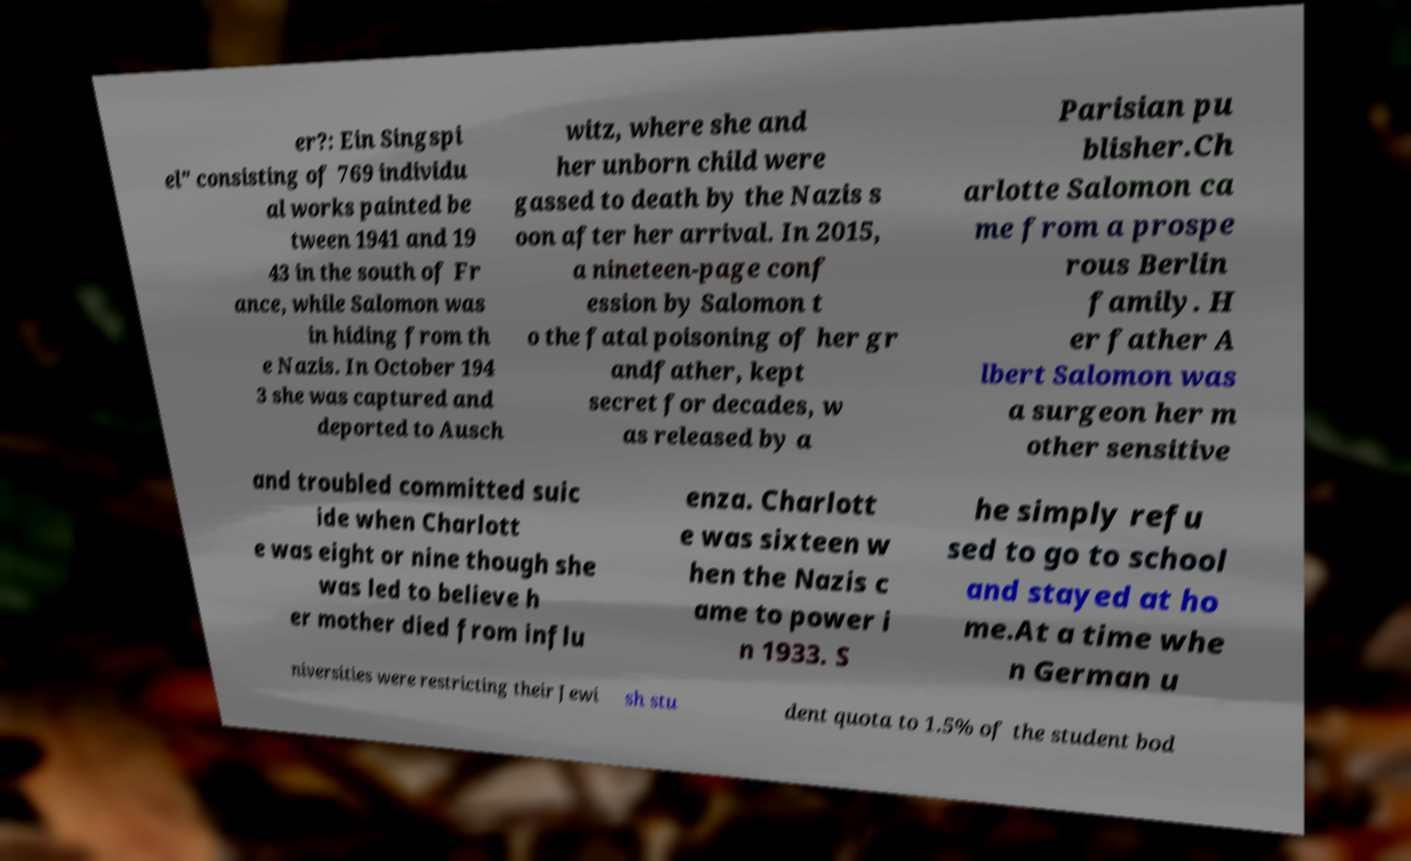There's text embedded in this image that I need extracted. Can you transcribe it verbatim? er?: Ein Singspi el" consisting of 769 individu al works painted be tween 1941 and 19 43 in the south of Fr ance, while Salomon was in hiding from th e Nazis. In October 194 3 she was captured and deported to Ausch witz, where she and her unborn child were gassed to death by the Nazis s oon after her arrival. In 2015, a nineteen-page conf ession by Salomon t o the fatal poisoning of her gr andfather, kept secret for decades, w as released by a Parisian pu blisher.Ch arlotte Salomon ca me from a prospe rous Berlin family. H er father A lbert Salomon was a surgeon her m other sensitive and troubled committed suic ide when Charlott e was eight or nine though she was led to believe h er mother died from influ enza. Charlott e was sixteen w hen the Nazis c ame to power i n 1933. S he simply refu sed to go to school and stayed at ho me.At a time whe n German u niversities were restricting their Jewi sh stu dent quota to 1.5% of the student bod 